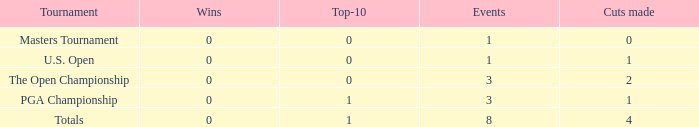For occurrences with values precisely 1, and 0 divisions made, what is the minimum quantity of top-10s? 0.0. 